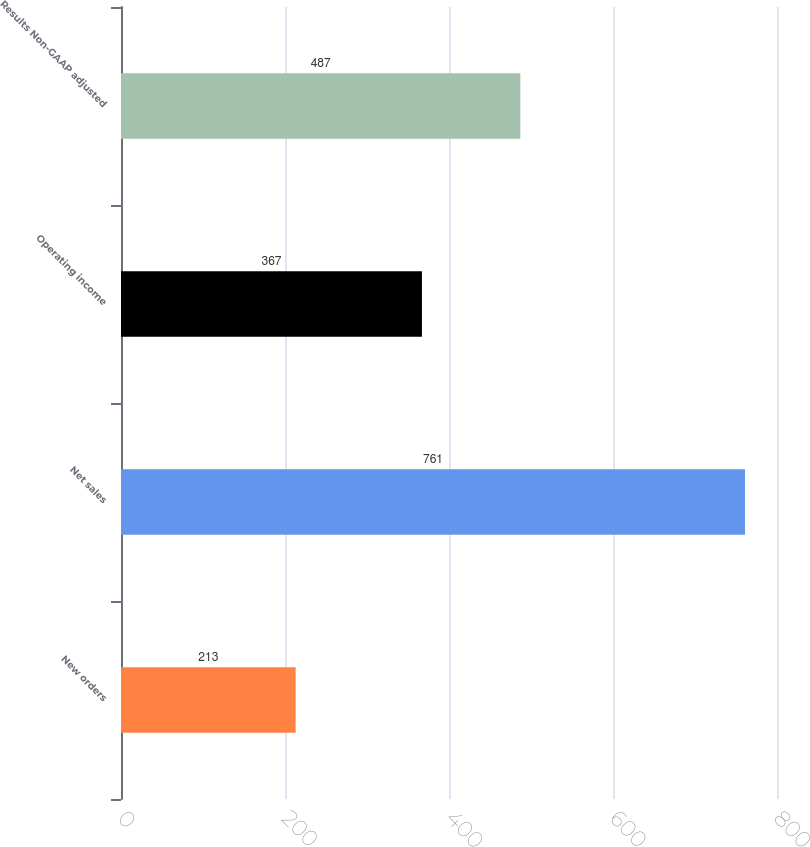Convert chart to OTSL. <chart><loc_0><loc_0><loc_500><loc_500><bar_chart><fcel>New orders<fcel>Net sales<fcel>Operating income<fcel>Results Non-GAAP adjusted<nl><fcel>213<fcel>761<fcel>367<fcel>487<nl></chart> 